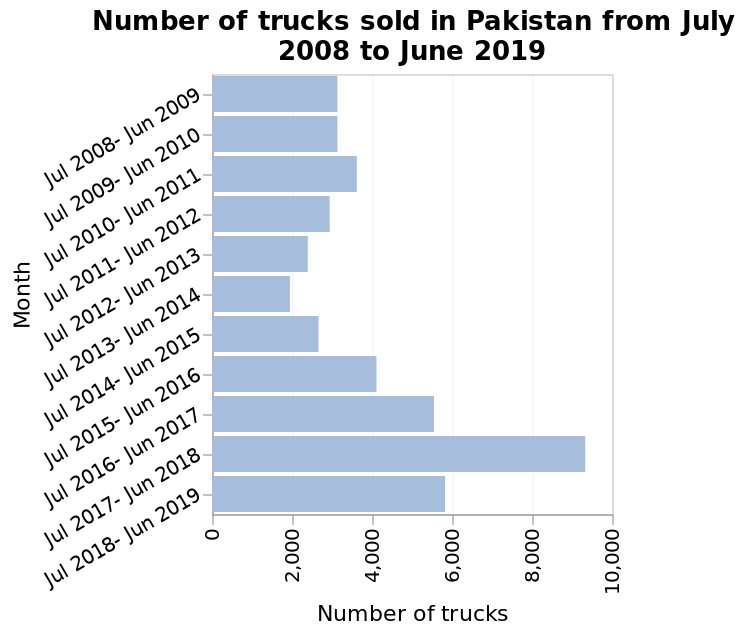<image>
What is the title of the bar diagram?  The title of the bar diagram is "Number of trucks sold in Pakistan from July 2008 to June 2019." Did the number of trucks sold in 2008/2010 differ from the number sold from July 2017 to June 2018? No, the same amount of trucks were sold in Pakistan in both periods, 2008/2010 and July 2017 to June 2018. Has there ever been a year with less than 2000 trucks sold in Pakistan? No, there hasn't been a year with fewer than 2000 trucks sold in Pakistan. What is the time period covered by the bar diagram? The bar diagram shows data from July 2008 to June 2019, representing the truck sales over this time period. What is the year range for the period where the same amount of trucks were sold? The two years with an equal number of truck sales are 2008 and 2010. 